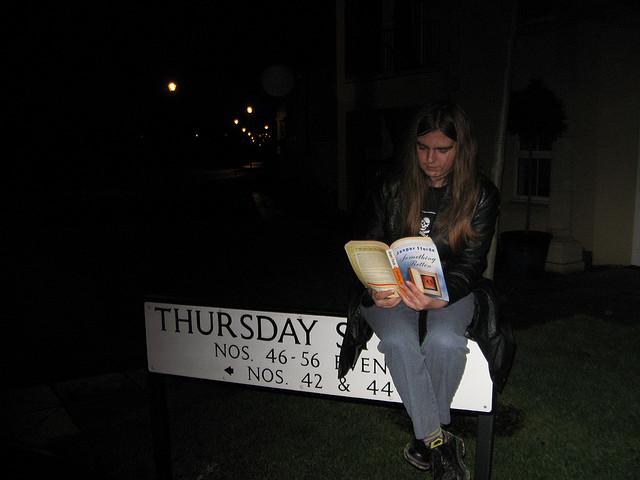Could that be a headlamp?
Write a very short answer. No. Is the woman's jacket black?
Quick response, please. Yes. Does the woman have her legs crossed?
Quick response, please. Yes. Does the person have a hat on?
Keep it brief. No. Is there a beer?
Give a very brief answer. No. Did she just catch the ball?
Give a very brief answer. No. How many different colors is the girl wearing?
Be succinct. 2. Are those street lights in the background?
Concise answer only. Yes. What color is the person's hair?
Answer briefly. Brown. What is the woman looking at?
Be succinct. Book. What is the woman holding?
Concise answer only. Book. What does the bright sign say?
Concise answer only. Thursday. 